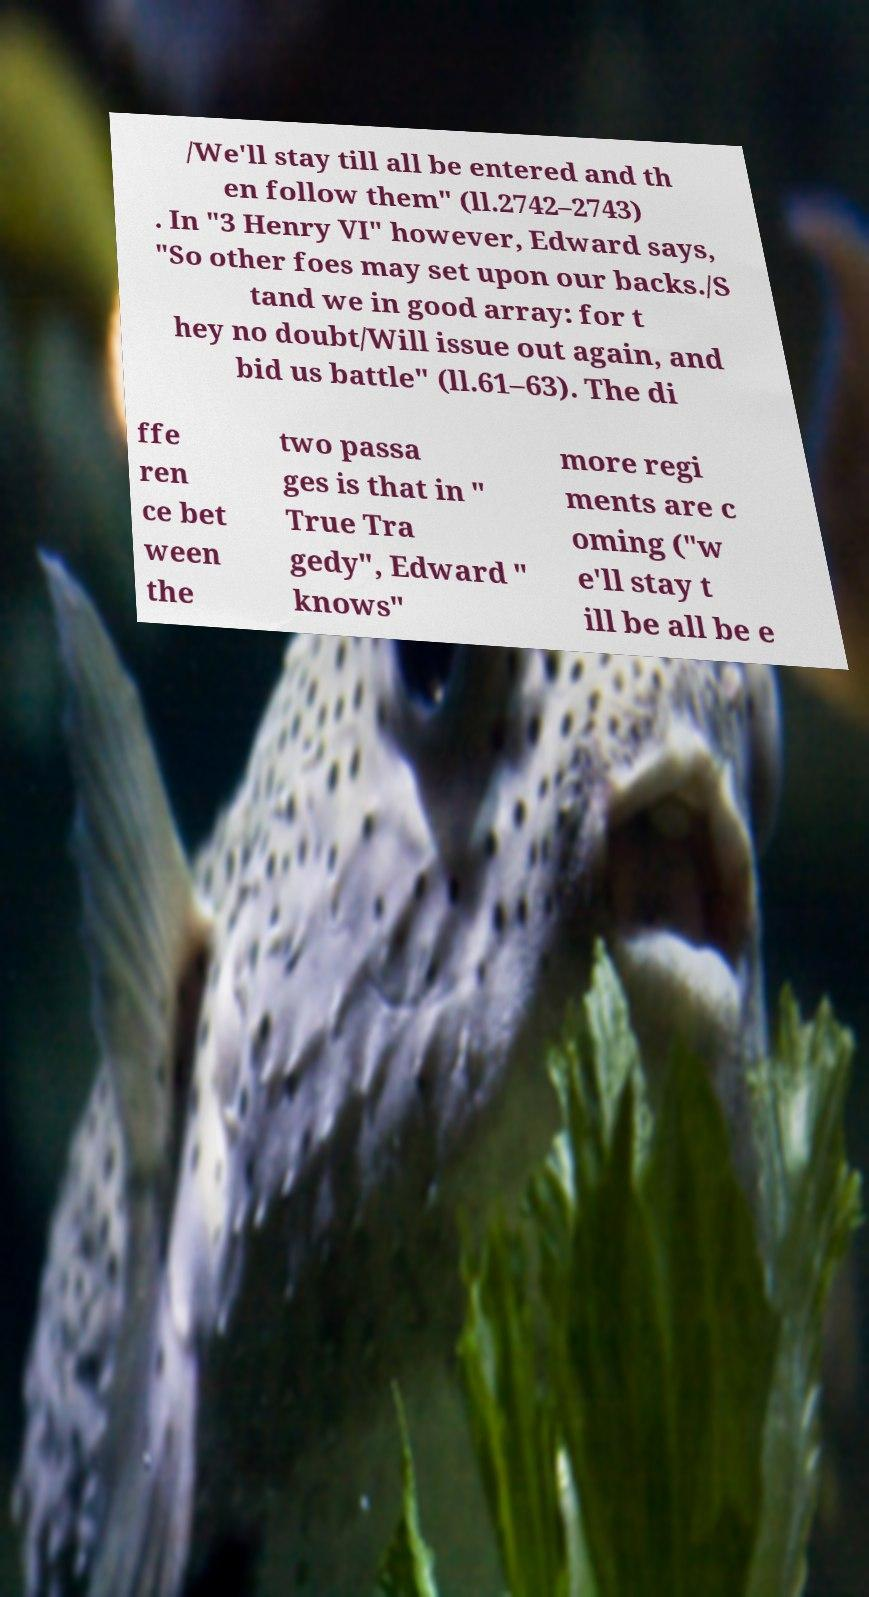Could you assist in decoding the text presented in this image and type it out clearly? /We'll stay till all be entered and th en follow them" (ll.2742–2743) . In "3 Henry VI" however, Edward says, "So other foes may set upon our backs./S tand we in good array: for t hey no doubt/Will issue out again, and bid us battle" (ll.61–63). The di ffe ren ce bet ween the two passa ges is that in " True Tra gedy", Edward " knows" more regi ments are c oming ("w e'll stay t ill be all be e 